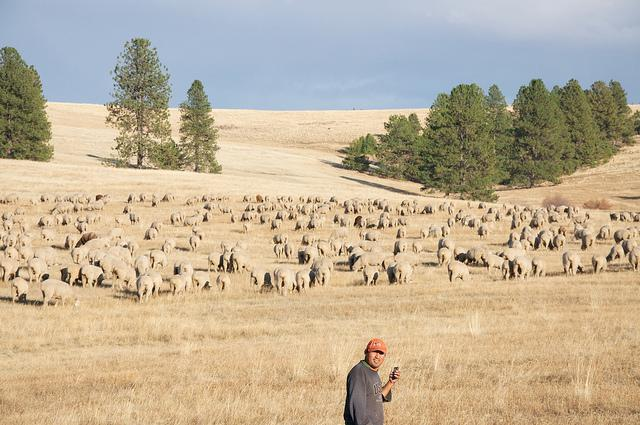Why is he standing far from the animals? Please explain your reasoning. avoid spooking. Most herd animals are easily startled, as they are prey to many different species of carnivores. if a visitor moves slowly, these animals will stay calm, just as the visitor is. 